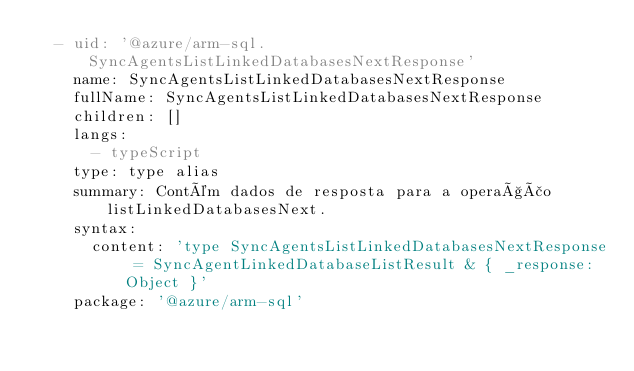<code> <loc_0><loc_0><loc_500><loc_500><_YAML_>  - uid: '@azure/arm-sql.SyncAgentsListLinkedDatabasesNextResponse'
    name: SyncAgentsListLinkedDatabasesNextResponse
    fullName: SyncAgentsListLinkedDatabasesNextResponse
    children: []
    langs:
      - typeScript
    type: type alias
    summary: Contém dados de resposta para a operação listLinkedDatabasesNext.
    syntax:
      content: 'type SyncAgentsListLinkedDatabasesNextResponse = SyncAgentLinkedDatabaseListResult & { _response: Object }'
    package: '@azure/arm-sql'</code> 